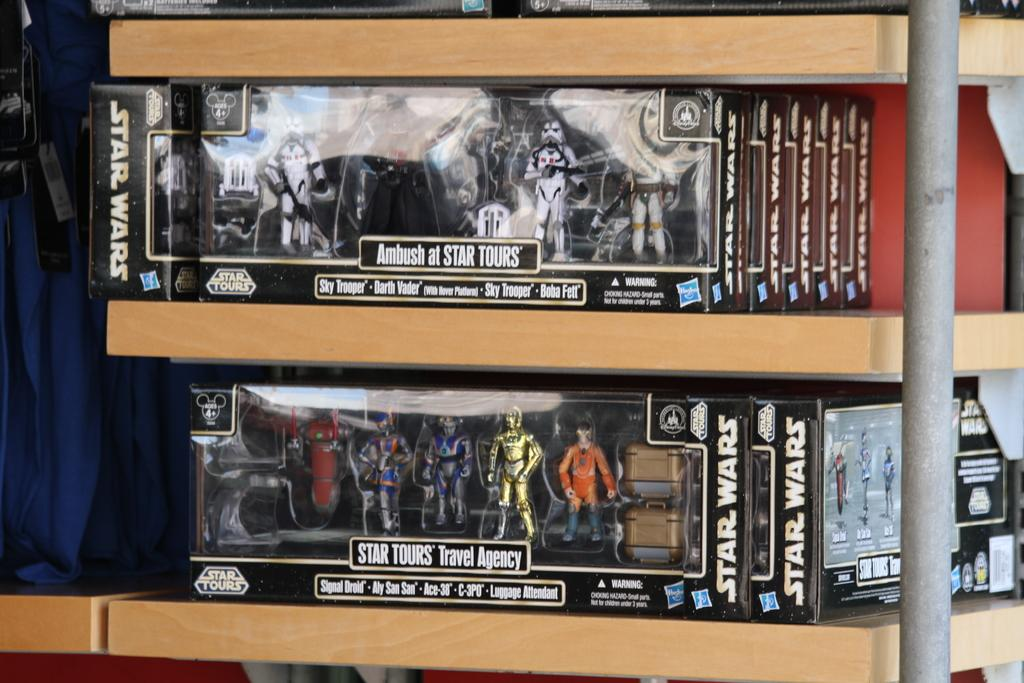What type of objects are in the image? There is a group of dolls in the image. How are the dolls stored or organized? The dolls are in cardboard boxes, which are placed in racks. What else can be seen in the image besides the dolls? There are tags on clothes and a pole visible in the image. What type of lunch is the beggar eating in the image? There is no beggar or lunch present in the image. Can you tell me the color of the flower on the pole in the image? There is no flower present on the pole in the image. 